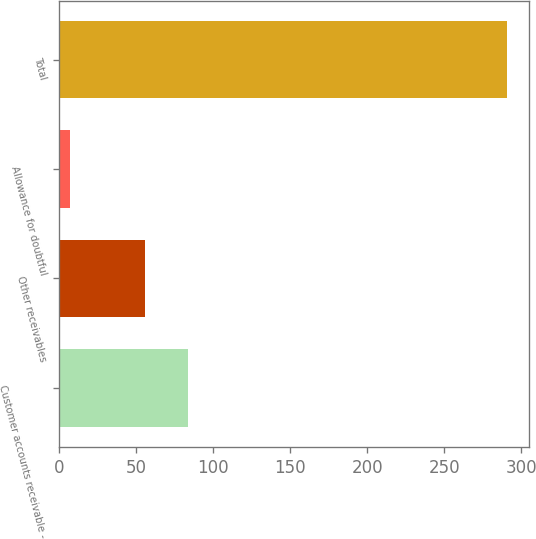Convert chart. <chart><loc_0><loc_0><loc_500><loc_500><bar_chart><fcel>Customer accounts receivable -<fcel>Other receivables<fcel>Allowance for doubtful<fcel>Total<nl><fcel>83.8<fcel>55.4<fcel>6.7<fcel>290.7<nl></chart> 